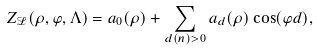Convert formula to latex. <formula><loc_0><loc_0><loc_500><loc_500>Z _ { \mathcal { L } } ( \rho , \varphi , \Lambda ) = a _ { 0 } ( \rho ) + \sum _ { d ( n ) > 0 } a _ { d } ( \rho ) \cos ( \varphi d ) ,</formula> 